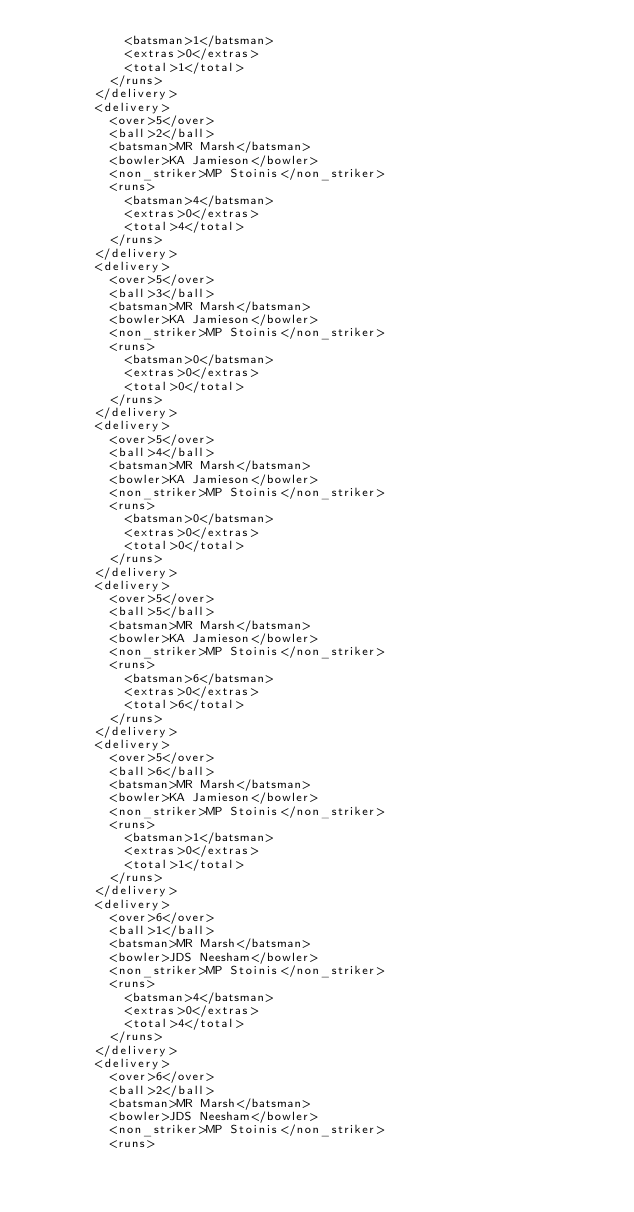Convert code to text. <code><loc_0><loc_0><loc_500><loc_500><_XML_>            <batsman>1</batsman>
            <extras>0</extras>
            <total>1</total>
          </runs>
        </delivery>
        <delivery>
          <over>5</over>
          <ball>2</ball>
          <batsman>MR Marsh</batsman>
          <bowler>KA Jamieson</bowler>
          <non_striker>MP Stoinis</non_striker>
          <runs>
            <batsman>4</batsman>
            <extras>0</extras>
            <total>4</total>
          </runs>
        </delivery>
        <delivery>
          <over>5</over>
          <ball>3</ball>
          <batsman>MR Marsh</batsman>
          <bowler>KA Jamieson</bowler>
          <non_striker>MP Stoinis</non_striker>
          <runs>
            <batsman>0</batsman>
            <extras>0</extras>
            <total>0</total>
          </runs>
        </delivery>
        <delivery>
          <over>5</over>
          <ball>4</ball>
          <batsman>MR Marsh</batsman>
          <bowler>KA Jamieson</bowler>
          <non_striker>MP Stoinis</non_striker>
          <runs>
            <batsman>0</batsman>
            <extras>0</extras>
            <total>0</total>
          </runs>
        </delivery>
        <delivery>
          <over>5</over>
          <ball>5</ball>
          <batsman>MR Marsh</batsman>
          <bowler>KA Jamieson</bowler>
          <non_striker>MP Stoinis</non_striker>
          <runs>
            <batsman>6</batsman>
            <extras>0</extras>
            <total>6</total>
          </runs>
        </delivery>
        <delivery>
          <over>5</over>
          <ball>6</ball>
          <batsman>MR Marsh</batsman>
          <bowler>KA Jamieson</bowler>
          <non_striker>MP Stoinis</non_striker>
          <runs>
            <batsman>1</batsman>
            <extras>0</extras>
            <total>1</total>
          </runs>
        </delivery>
        <delivery>
          <over>6</over>
          <ball>1</ball>
          <batsman>MR Marsh</batsman>
          <bowler>JDS Neesham</bowler>
          <non_striker>MP Stoinis</non_striker>
          <runs>
            <batsman>4</batsman>
            <extras>0</extras>
            <total>4</total>
          </runs>
        </delivery>
        <delivery>
          <over>6</over>
          <ball>2</ball>
          <batsman>MR Marsh</batsman>
          <bowler>JDS Neesham</bowler>
          <non_striker>MP Stoinis</non_striker>
          <runs></code> 